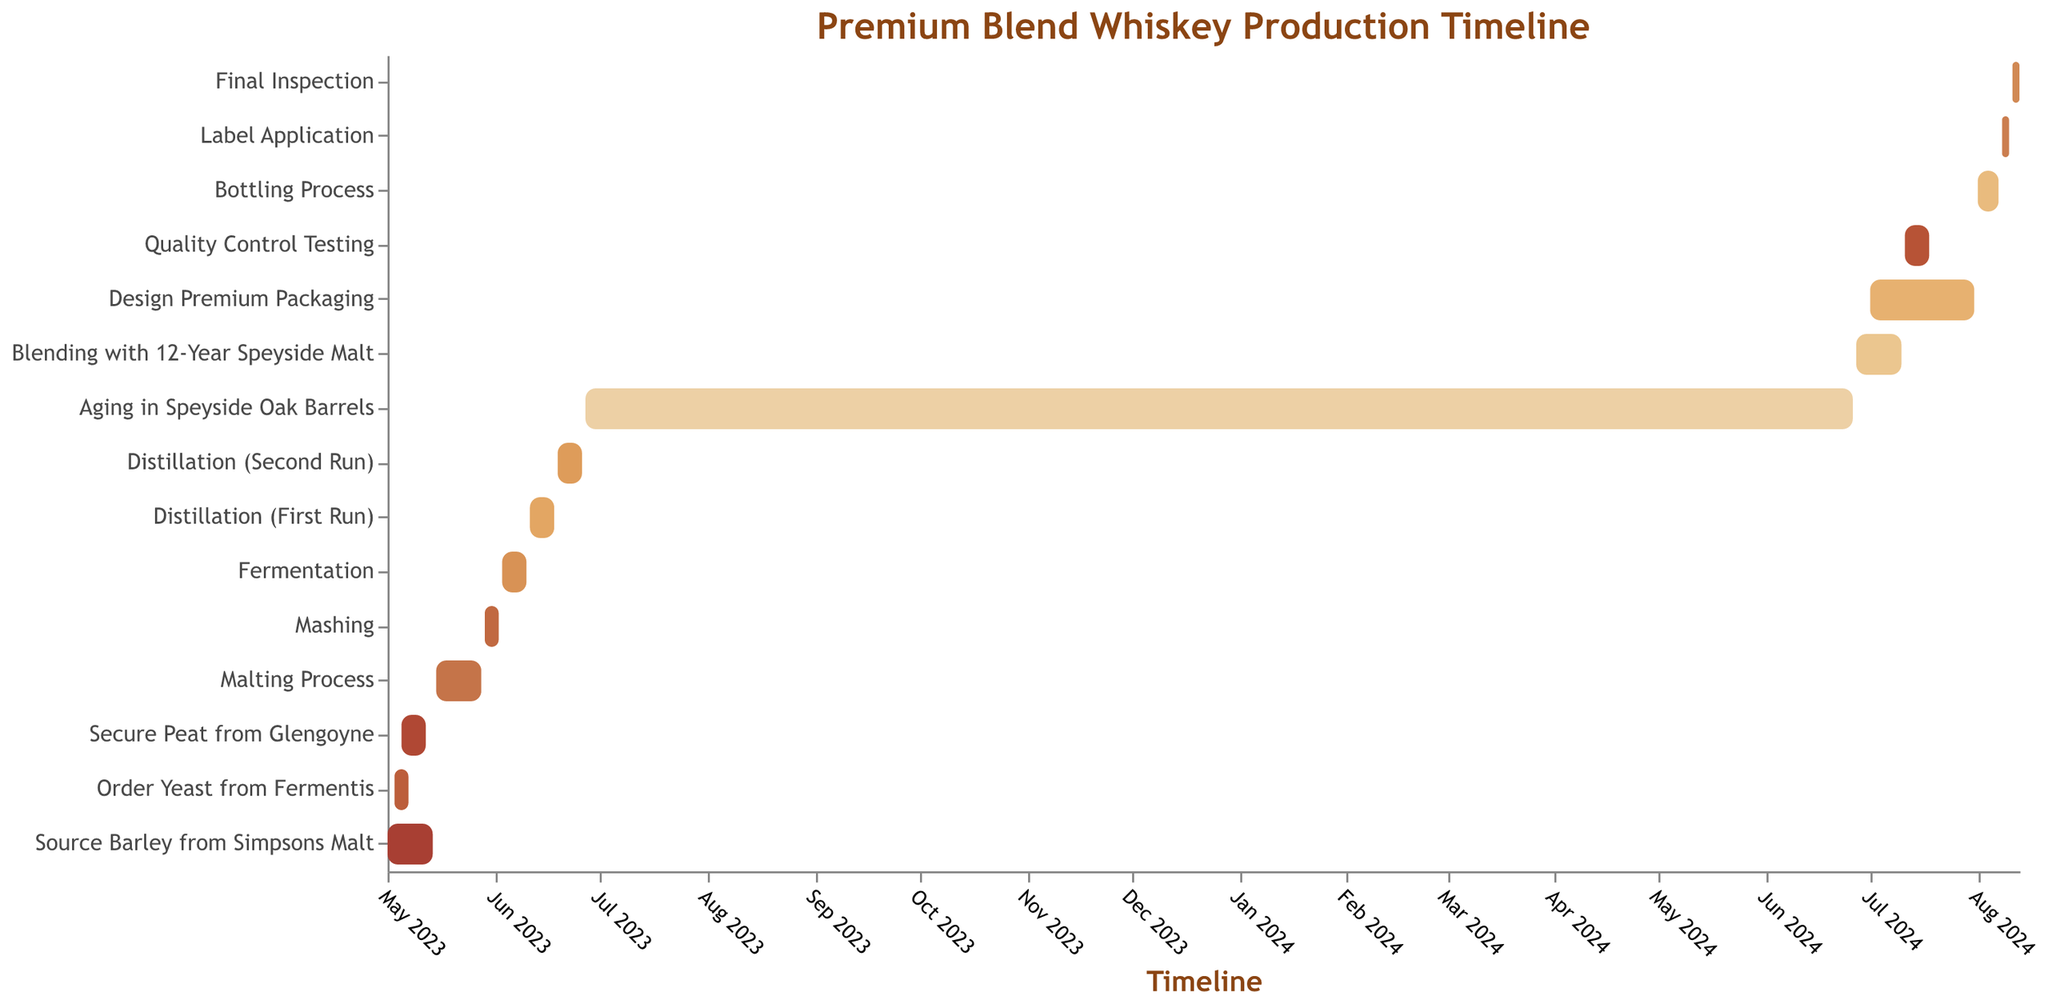What is the duration of the Malting Process? To determine the duration of the Malting Process, look at the start and end dates. It starts on May 15, 2023, and ends on May 28, 2023. Calculating the difference between these dates gives 14 days.
Answer: 14 days How many tasks are completed by the end of June 2023? Tasks completed by the end of June 2023 include Source Barley from Simpsons Malt, Order Yeast from Fermentis, Secure Peat from Glengoyne, Malting Process, Mashing, Fermentation, Distillation (First Run), and Distillation (Second Run). That makes 8 tasks in total.
Answer: 8 tasks Which task has the longest duration? To find the longest duration task, compare the intervals between the start and end dates of the tasks. Aging in Speyside Oak Barrels spans from June 27, 2023, to June 26, 2024, giving it the longest duration of 366 days (including a leap year).
Answer: Aging in Speyside Oak Barrels Which tasks overlap in June 2024? The tasks that take place in June 2024 include the end of Aging in Speyside Oak Barrels (ends June 26, 2024), the start and end of Blending with 12-Year Speyside Malt (June 27, 2024, to July 10, 2024), and the start of Designing Premium Packaging (starts July 1, 2024).
Answer: Aging in Speyside Oak Barrels, Blending with 12-Year Speyside Malt, Design Premium Packaging When does the Bottling Process start, and how long does it last? The Bottling Process starts on August 1, 2024, and ends on August 7, 2024. The duration is from August 1 to August 7, which is 7 days.
Answer: August 1, 2024; 7 days What is the sequence of events for the tasks from "Fermentation" to "Blending with 12-Year Speyside Malt"? The sequence of events is: 1. Fermentation (June 3, 2023, to June 10, 2023), 2. Distillation (First Run) (June 11, 2023, to June 18, 2023), 3. Distillation (Second Run) (June 19, 2023, to June 26, 2023), 4. Aging in Speyside Oak Barrels (June 27, 2023, to June 26, 2024), 5. Blending with 12-Year Speyside Malt (June 27, 2024, to July 10, 2024).
Answer: Fermentation -> Distillation (First Run) -> Distillation (Second Run) -> Aging in Speyside Oak Barrels -> Blending with 12-Year Speyside Malt Does Quality Control Testing overlap with any other tasks? Quality Control Testing runs from July 11, 2024, to July 18, 2024. This period overlaps with the task of Designing Premium Packaging, which runs from July 1, 2024, to July 31, 2024.
Answer: Yes What is the gap between Aging in Speyside Oak Barrels and Quality Control Testing? Aging in Speyside Oak Barrels ends on June 26, 2024, and Quality Control Testing starts on July 11, 2024. The gap between these dates is 14 days.
Answer: 14 days 